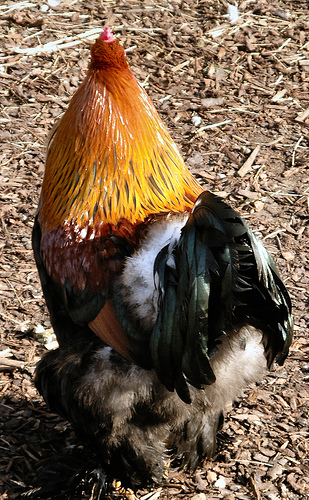<image>
Is there a rooster behind the ground? No. The rooster is not behind the ground. From this viewpoint, the rooster appears to be positioned elsewhere in the scene. 